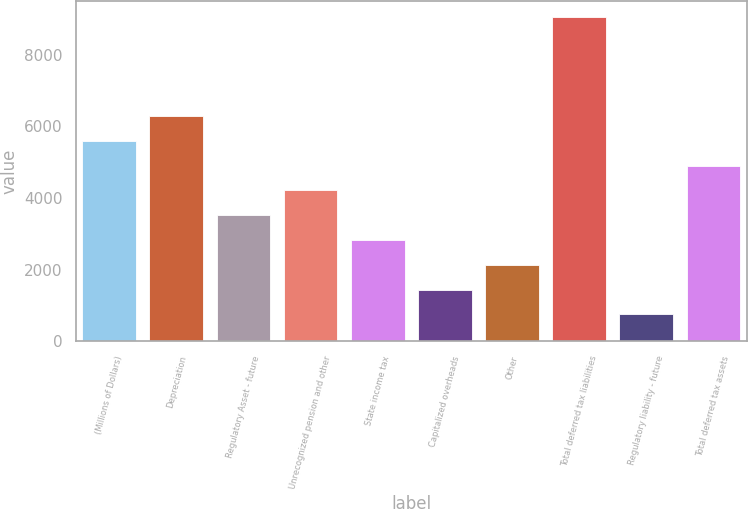<chart> <loc_0><loc_0><loc_500><loc_500><bar_chart><fcel>(Millions of Dollars)<fcel>Depreciation<fcel>Regulatory Asset - future<fcel>Unrecognized pension and other<fcel>State income tax<fcel>Capitalized overheads<fcel>Other<fcel>Total deferred tax liabilities<fcel>Regulatory liability - future<fcel>Total deferred tax assets<nl><fcel>5591<fcel>6282<fcel>3518<fcel>4209<fcel>2827<fcel>1445<fcel>2136<fcel>9046<fcel>754<fcel>4900<nl></chart> 